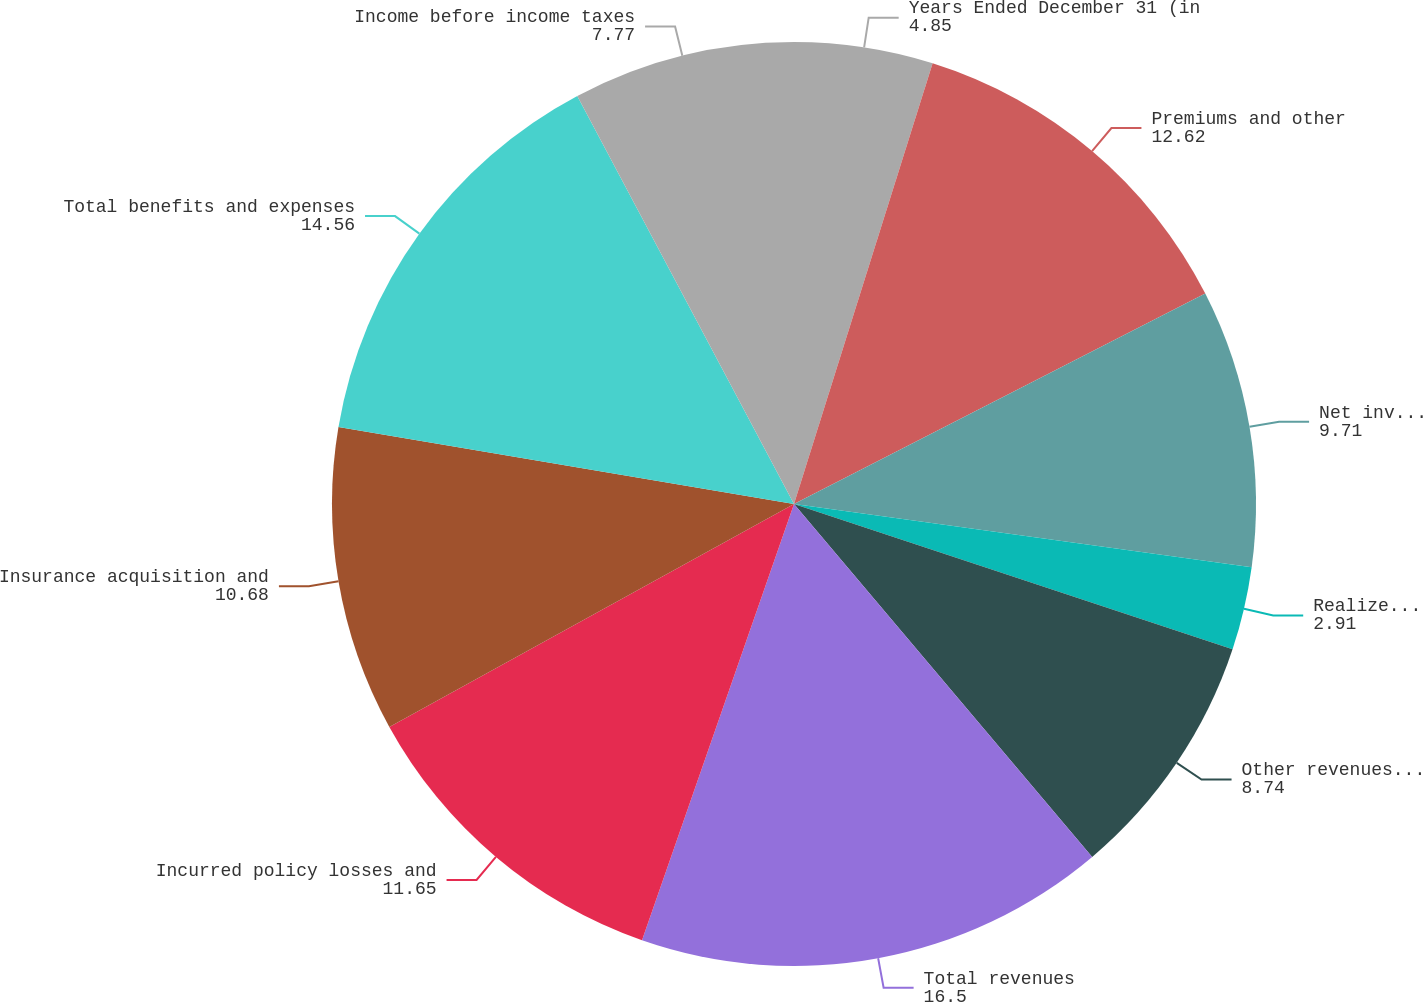Convert chart to OTSL. <chart><loc_0><loc_0><loc_500><loc_500><pie_chart><fcel>Years Ended December 31 (in<fcel>Premiums and other<fcel>Net investment income<fcel>Realized capital gains<fcel>Other revenues (b)<fcel>Total revenues<fcel>Incurred policy losses and<fcel>Insurance acquisition and<fcel>Total benefits and expenses<fcel>Income before income taxes<nl><fcel>4.85%<fcel>12.62%<fcel>9.71%<fcel>2.91%<fcel>8.74%<fcel>16.5%<fcel>11.65%<fcel>10.68%<fcel>14.56%<fcel>7.77%<nl></chart> 